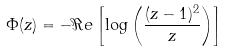<formula> <loc_0><loc_0><loc_500><loc_500>\Phi ( z ) = - \Re e \left [ \log \left ( { \frac { ( z - 1 ) ^ { 2 } } { z } } \right ) \right ]</formula> 